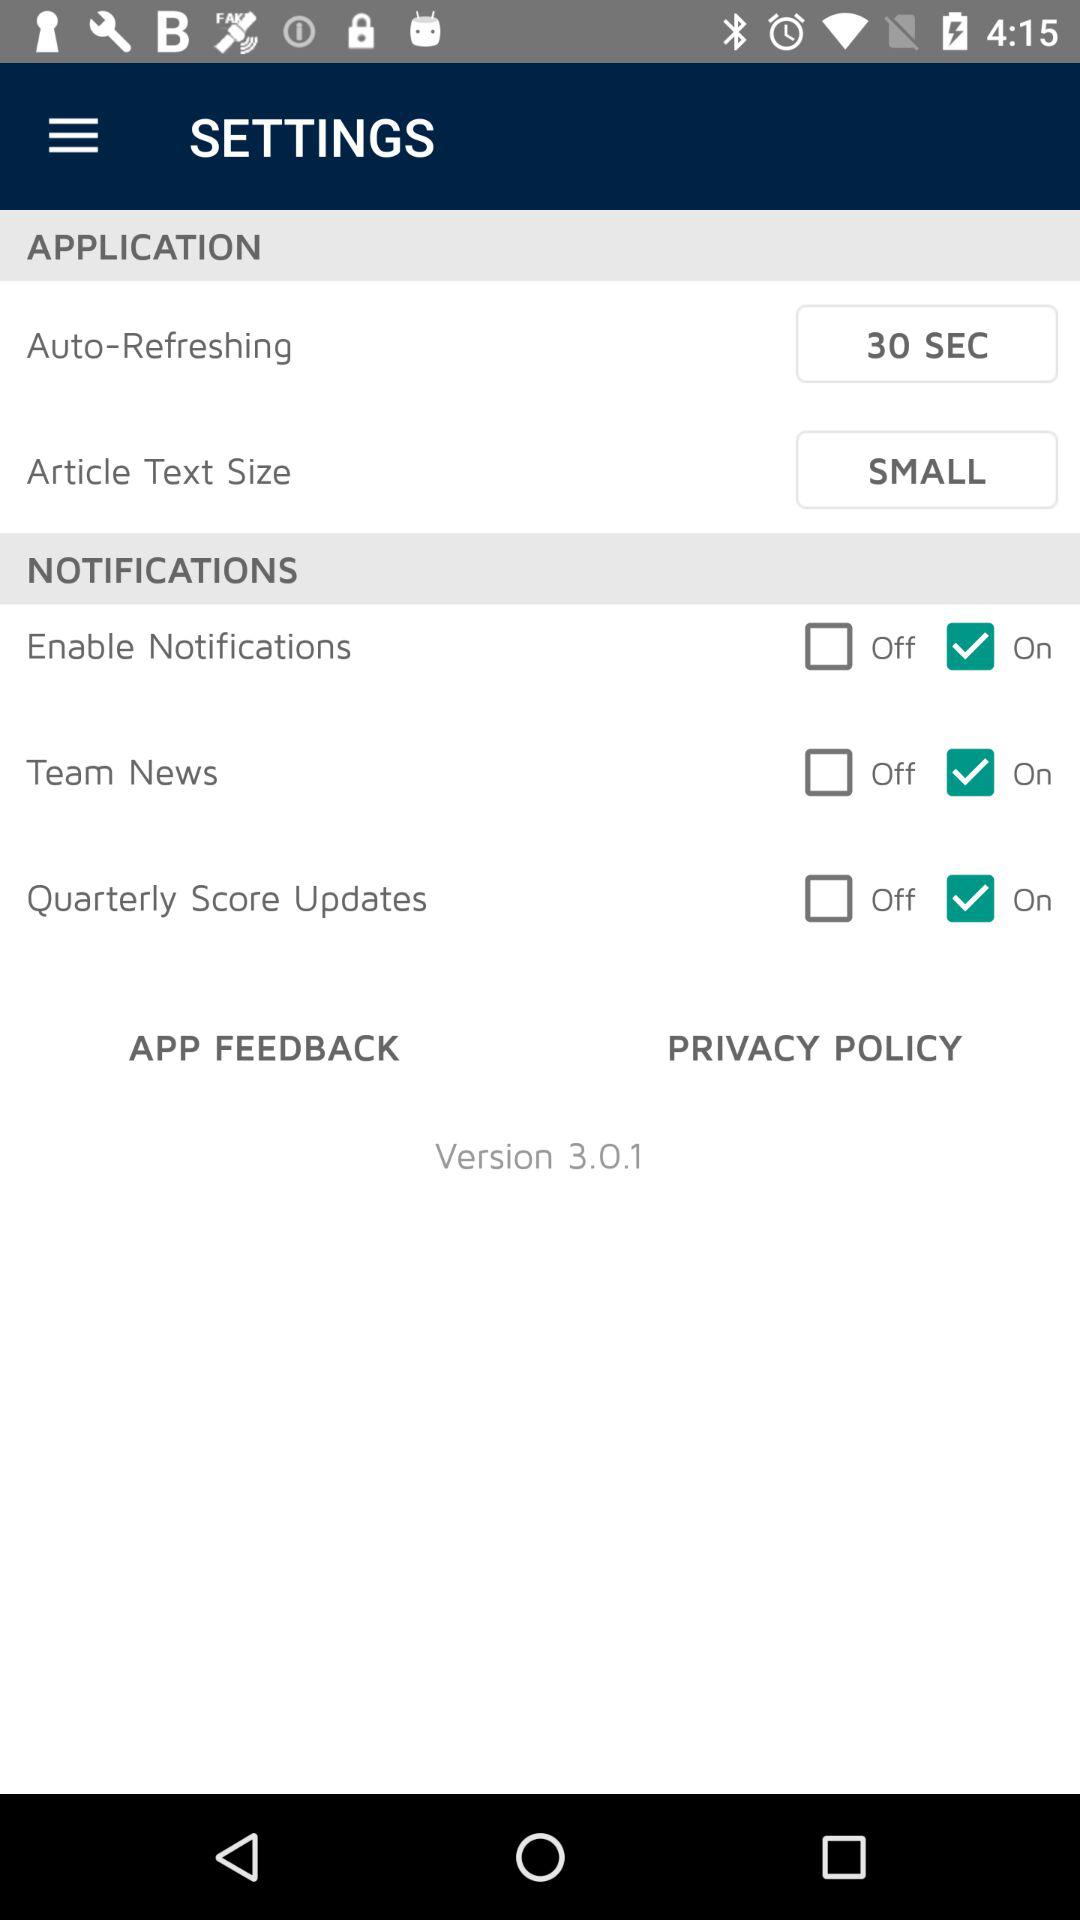What is the version of the app?
Answer the question using a single word or phrase. 3.0.1 